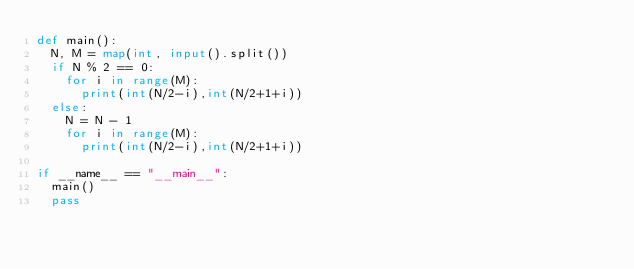Convert code to text. <code><loc_0><loc_0><loc_500><loc_500><_Python_>def main():
	N, M = map(int, input().split())
	if N % 2 == 0:
		for i in range(M):
			print(int(N/2-i),int(N/2+1+i))
	else:
		N = N - 1
		for i in range(M):
			print(int(N/2-i),int(N/2+1+i))
			
if __name__ == "__main__":
  main()
  pass</code> 